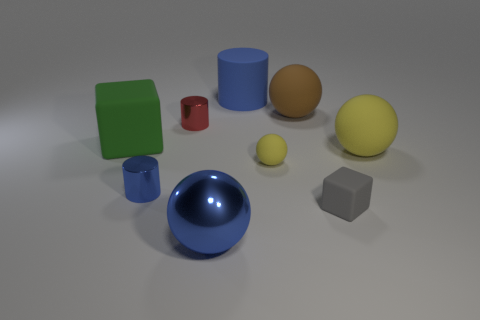Subtract all gray cylinders. How many yellow spheres are left? 2 Add 1 cyan rubber cubes. How many objects exist? 10 Subtract all red cylinders. How many cylinders are left? 2 Subtract 1 cylinders. How many cylinders are left? 2 Subtract all blue spheres. How many spheres are left? 3 Subtract all cubes. How many objects are left? 7 Subtract all gray cylinders. Subtract all purple balls. How many cylinders are left? 3 Subtract 0 gray spheres. How many objects are left? 9 Subtract all big blue matte objects. Subtract all small metal objects. How many objects are left? 6 Add 8 tiny cylinders. How many tiny cylinders are left? 10 